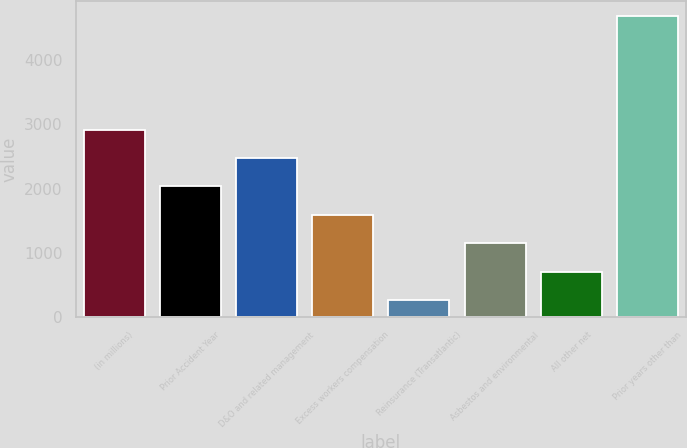Convert chart. <chart><loc_0><loc_0><loc_500><loc_500><bar_chart><fcel>(in millions)<fcel>Prior Accident Year<fcel>D&O and related management<fcel>Excess workers compensation<fcel>Reinsurance (Transatlantic)<fcel>Asbestos and environmental<fcel>All other net<fcel>Prior years other than<nl><fcel>2915.6<fcel>2033.4<fcel>2474.5<fcel>1592.3<fcel>269<fcel>1151.2<fcel>710.1<fcel>4680<nl></chart> 